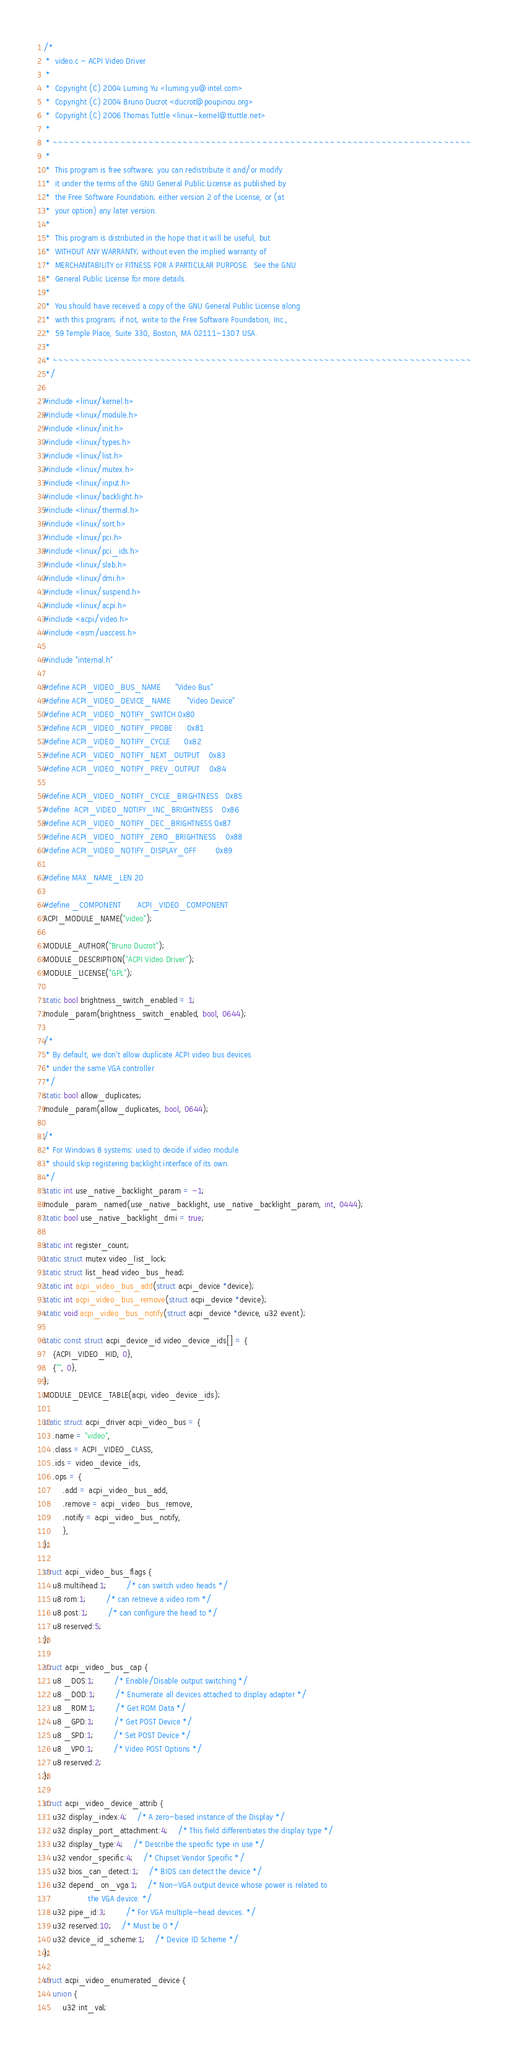<code> <loc_0><loc_0><loc_500><loc_500><_C_>/*
 *  video.c - ACPI Video Driver
 *
 *  Copyright (C) 2004 Luming Yu <luming.yu@intel.com>
 *  Copyright (C) 2004 Bruno Ducrot <ducrot@poupinou.org>
 *  Copyright (C) 2006 Thomas Tuttle <linux-kernel@ttuttle.net>
 *
 * ~~~~~~~~~~~~~~~~~~~~~~~~~~~~~~~~~~~~~~~~~~~~~~~~~~~~~~~~~~~~~~~~~~~~~~~~~~
 *
 *  This program is free software; you can redistribute it and/or modify
 *  it under the terms of the GNU General Public License as published by
 *  the Free Software Foundation; either version 2 of the License, or (at
 *  your option) any later version.
 *
 *  This program is distributed in the hope that it will be useful, but
 *  WITHOUT ANY WARRANTY; without even the implied warranty of
 *  MERCHANTABILITY or FITNESS FOR A PARTICULAR PURPOSE.  See the GNU
 *  General Public License for more details.
 *
 *  You should have received a copy of the GNU General Public License along
 *  with this program; if not, write to the Free Software Foundation, Inc.,
 *  59 Temple Place, Suite 330, Boston, MA 02111-1307 USA.
 *
 * ~~~~~~~~~~~~~~~~~~~~~~~~~~~~~~~~~~~~~~~~~~~~~~~~~~~~~~~~~~~~~~~~~~~~~~~~~~
 */

#include <linux/kernel.h>
#include <linux/module.h>
#include <linux/init.h>
#include <linux/types.h>
#include <linux/list.h>
#include <linux/mutex.h>
#include <linux/input.h>
#include <linux/backlight.h>
#include <linux/thermal.h>
#include <linux/sort.h>
#include <linux/pci.h>
#include <linux/pci_ids.h>
#include <linux/slab.h>
#include <linux/dmi.h>
#include <linux/suspend.h>
#include <linux/acpi.h>
#include <acpi/video.h>
#include <asm/uaccess.h>

#include "internal.h"

#define ACPI_VIDEO_BUS_NAME		"Video Bus"
#define ACPI_VIDEO_DEVICE_NAME		"Video Device"
#define ACPI_VIDEO_NOTIFY_SWITCH	0x80
#define ACPI_VIDEO_NOTIFY_PROBE		0x81
#define ACPI_VIDEO_NOTIFY_CYCLE		0x82
#define ACPI_VIDEO_NOTIFY_NEXT_OUTPUT	0x83
#define ACPI_VIDEO_NOTIFY_PREV_OUTPUT	0x84

#define ACPI_VIDEO_NOTIFY_CYCLE_BRIGHTNESS	0x85
#define	ACPI_VIDEO_NOTIFY_INC_BRIGHTNESS	0x86
#define ACPI_VIDEO_NOTIFY_DEC_BRIGHTNESS	0x87
#define ACPI_VIDEO_NOTIFY_ZERO_BRIGHTNESS	0x88
#define ACPI_VIDEO_NOTIFY_DISPLAY_OFF		0x89

#define MAX_NAME_LEN	20

#define _COMPONENT		ACPI_VIDEO_COMPONENT
ACPI_MODULE_NAME("video");

MODULE_AUTHOR("Bruno Ducrot");
MODULE_DESCRIPTION("ACPI Video Driver");
MODULE_LICENSE("GPL");

static bool brightness_switch_enabled = 1;
module_param(brightness_switch_enabled, bool, 0644);

/*
 * By default, we don't allow duplicate ACPI video bus devices
 * under the same VGA controller
 */
static bool allow_duplicates;
module_param(allow_duplicates, bool, 0644);

/*
 * For Windows 8 systems: used to decide if video module
 * should skip registering backlight interface of its own.
 */
static int use_native_backlight_param = -1;
module_param_named(use_native_backlight, use_native_backlight_param, int, 0444);
static bool use_native_backlight_dmi = true;

static int register_count;
static struct mutex video_list_lock;
static struct list_head video_bus_head;
static int acpi_video_bus_add(struct acpi_device *device);
static int acpi_video_bus_remove(struct acpi_device *device);
static void acpi_video_bus_notify(struct acpi_device *device, u32 event);

static const struct acpi_device_id video_device_ids[] = {
	{ACPI_VIDEO_HID, 0},
	{"", 0},
};
MODULE_DEVICE_TABLE(acpi, video_device_ids);

static struct acpi_driver acpi_video_bus = {
	.name = "video",
	.class = ACPI_VIDEO_CLASS,
	.ids = video_device_ids,
	.ops = {
		.add = acpi_video_bus_add,
		.remove = acpi_video_bus_remove,
		.notify = acpi_video_bus_notify,
		},
};

struct acpi_video_bus_flags {
	u8 multihead:1;		/* can switch video heads */
	u8 rom:1;		/* can retrieve a video rom */
	u8 post:1;		/* can configure the head to */
	u8 reserved:5;
};

struct acpi_video_bus_cap {
	u8 _DOS:1;		/* Enable/Disable output switching */
	u8 _DOD:1;		/* Enumerate all devices attached to display adapter */
	u8 _ROM:1;		/* Get ROM Data */
	u8 _GPD:1;		/* Get POST Device */
	u8 _SPD:1;		/* Set POST Device */
	u8 _VPO:1;		/* Video POST Options */
	u8 reserved:2;
};

struct acpi_video_device_attrib {
	u32 display_index:4;	/* A zero-based instance of the Display */
	u32 display_port_attachment:4;	/* This field differentiates the display type */
	u32 display_type:4;	/* Describe the specific type in use */
	u32 vendor_specific:4;	/* Chipset Vendor Specific */
	u32 bios_can_detect:1;	/* BIOS can detect the device */
	u32 depend_on_vga:1;	/* Non-VGA output device whose power is related to
				   the VGA device. */
	u32 pipe_id:3;		/* For VGA multiple-head devices. */
	u32 reserved:10;	/* Must be 0 */
	u32 device_id_scheme:1;	/* Device ID Scheme */
};

struct acpi_video_enumerated_device {
	union {
		u32 int_val;</code> 